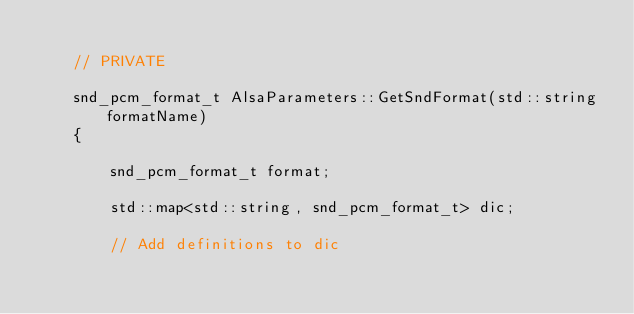<code> <loc_0><loc_0><loc_500><loc_500><_C++_>
	// PRIVATE

	snd_pcm_format_t AlsaParameters::GetSndFormat(std::string formatName)
	{

		snd_pcm_format_t format;

		std::map<std::string, snd_pcm_format_t> dic;

		// Add definitions to dic</code> 